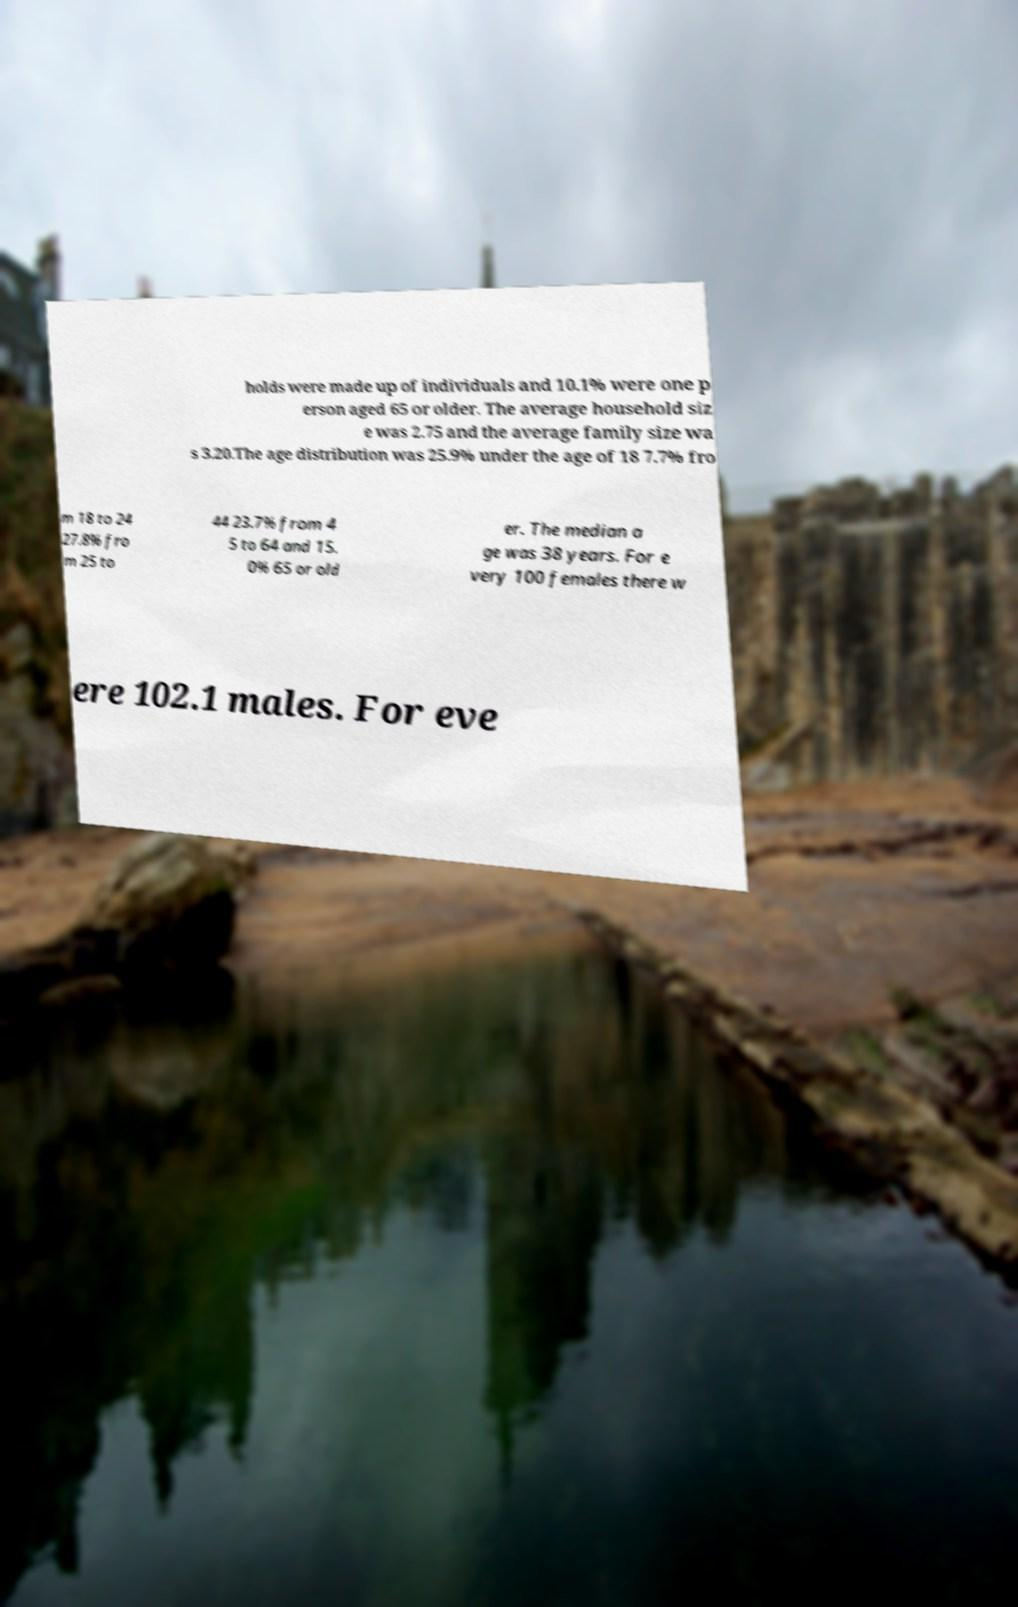Can you accurately transcribe the text from the provided image for me? holds were made up of individuals and 10.1% were one p erson aged 65 or older. The average household siz e was 2.75 and the average family size wa s 3.20.The age distribution was 25.9% under the age of 18 7.7% fro m 18 to 24 27.8% fro m 25 to 44 23.7% from 4 5 to 64 and 15. 0% 65 or old er. The median a ge was 38 years. For e very 100 females there w ere 102.1 males. For eve 